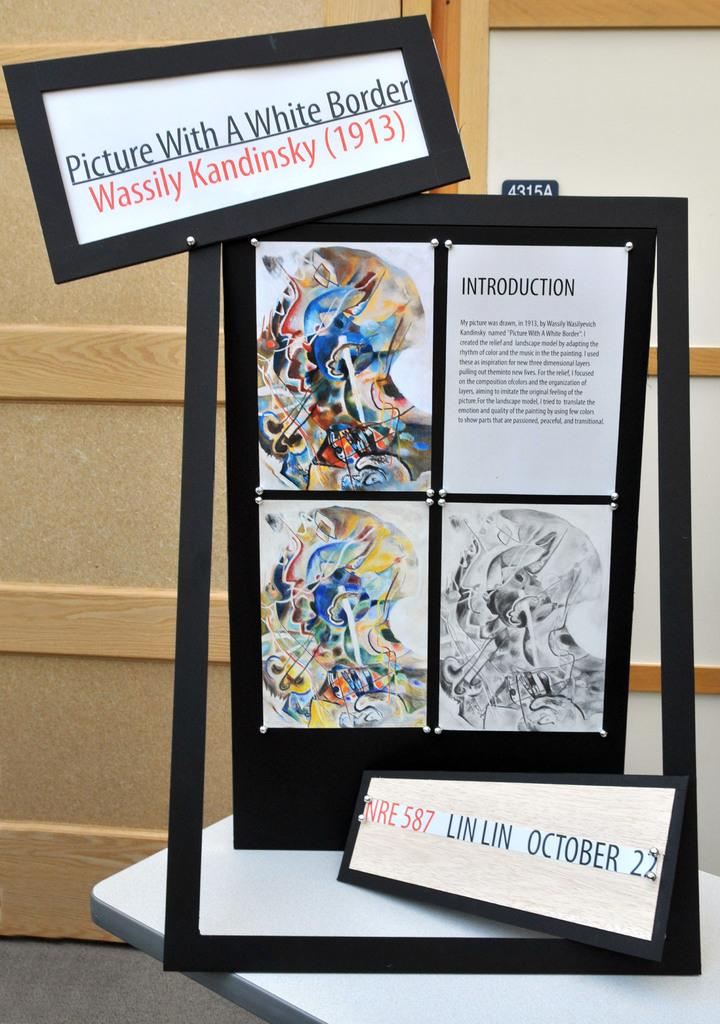<image>
Write a terse but informative summary of the picture. A sign for an exhibit titled Picture With A White Border by Wassily Kandinsky. 